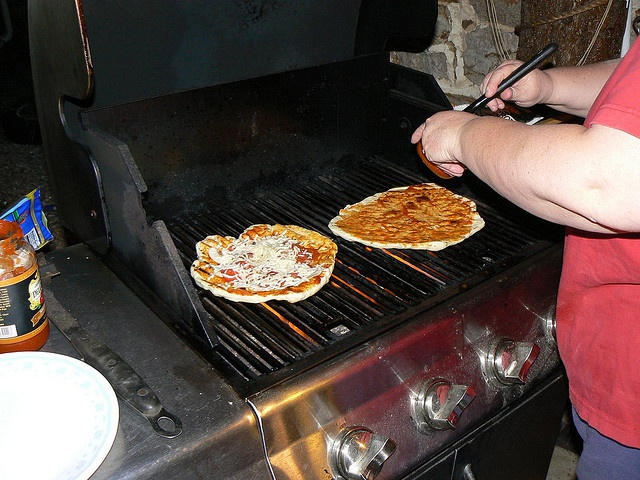Describe the objects in this image and their specific colors. I can see oven in black, maroon, gray, and ivory tones, people in black, salmon, white, tan, and brown tones, pizza in black, beige, tan, and red tones, and pizza in black, red, and orange tones in this image. 